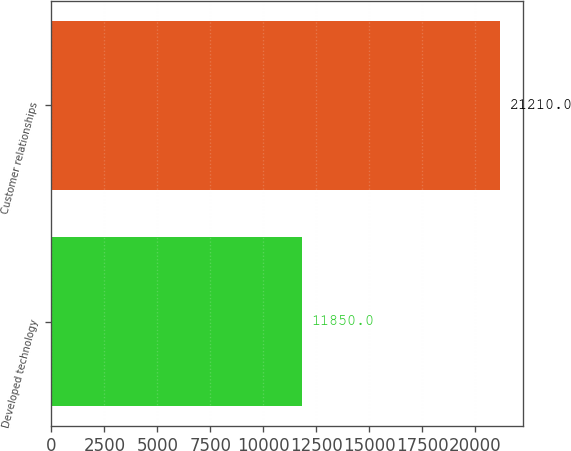Convert chart to OTSL. <chart><loc_0><loc_0><loc_500><loc_500><bar_chart><fcel>Developed technology<fcel>Customer relationships<nl><fcel>11850<fcel>21210<nl></chart> 